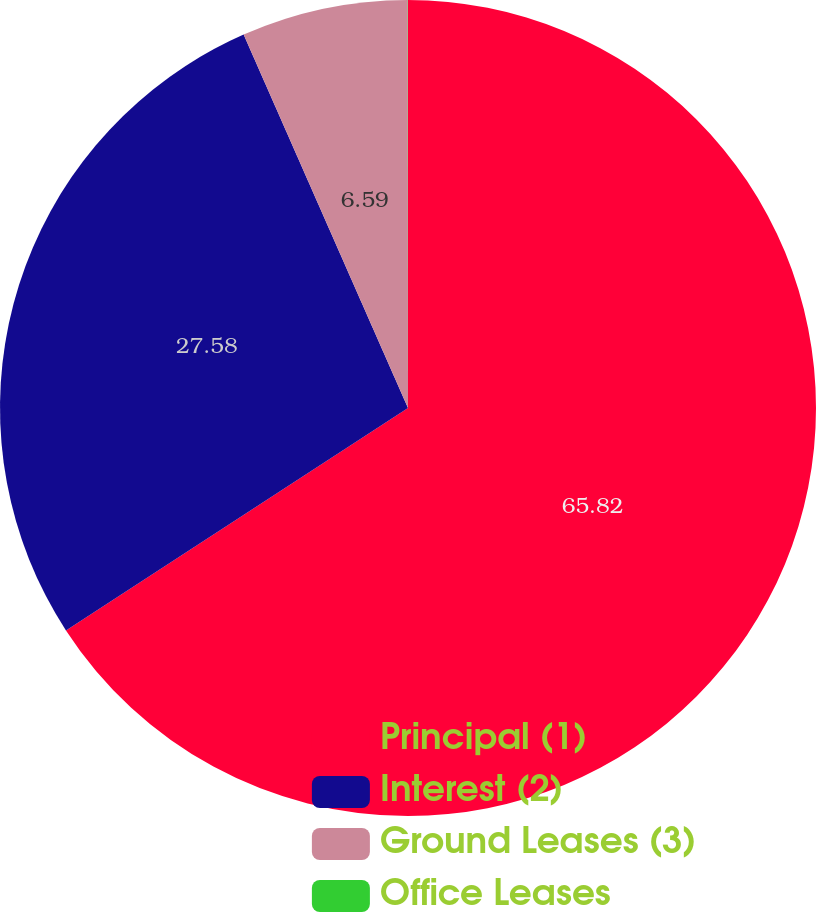Convert chart. <chart><loc_0><loc_0><loc_500><loc_500><pie_chart><fcel>Principal (1)<fcel>Interest (2)<fcel>Ground Leases (3)<fcel>Office Leases<nl><fcel>65.83%<fcel>27.58%<fcel>6.59%<fcel>0.01%<nl></chart> 